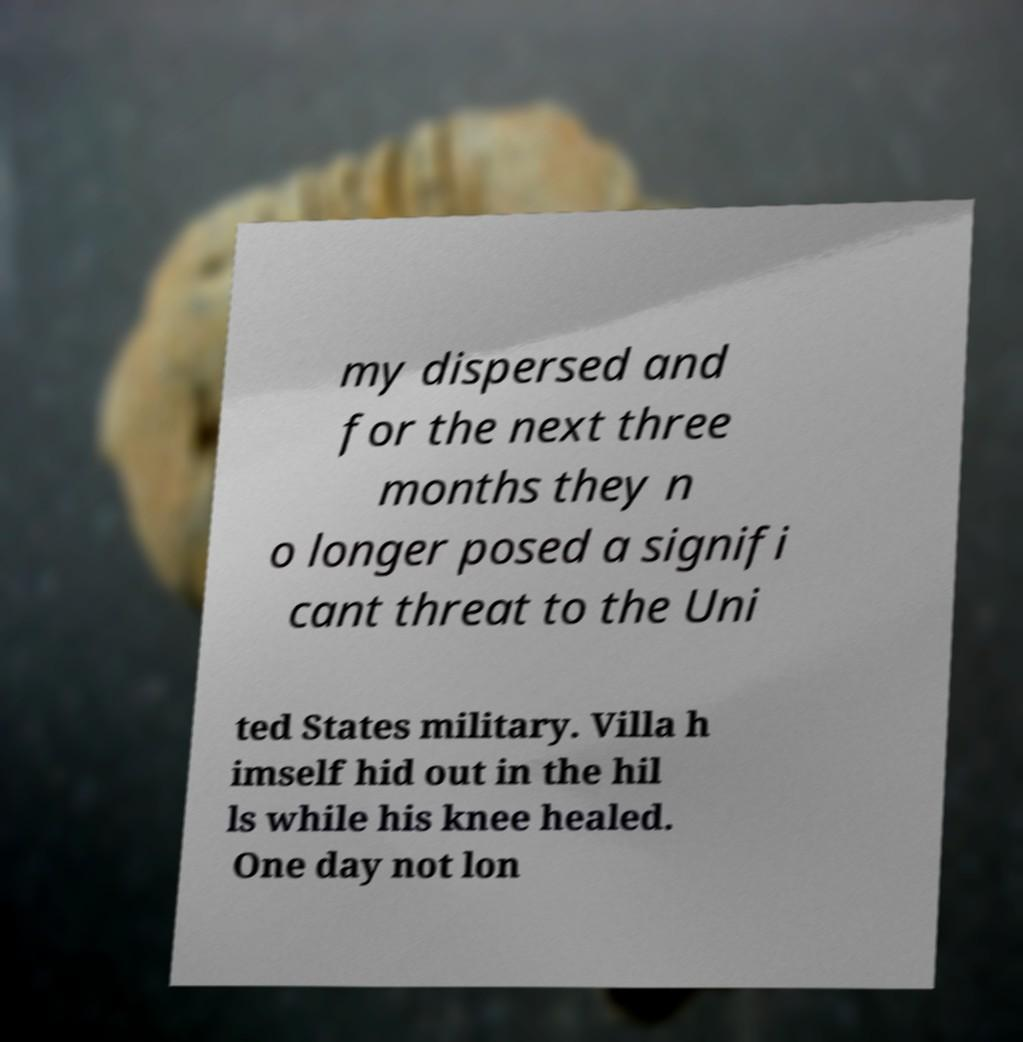Please identify and transcribe the text found in this image. my dispersed and for the next three months they n o longer posed a signifi cant threat to the Uni ted States military. Villa h imself hid out in the hil ls while his knee healed. One day not lon 